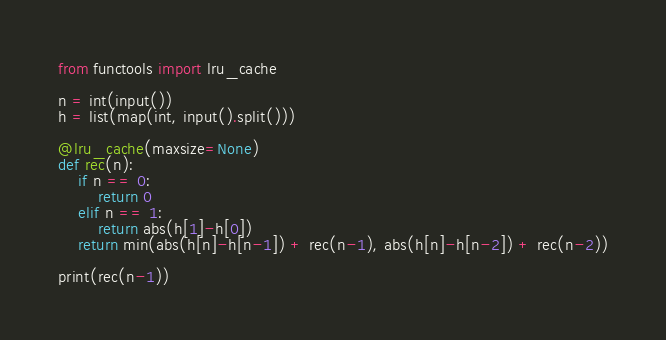Convert code to text. <code><loc_0><loc_0><loc_500><loc_500><_Python_>from functools import lru_cache

n = int(input())
h = list(map(int, input().split()))

@lru_cache(maxsize=None)
def rec(n):
    if n == 0:
        return 0
    elif n == 1:
        return abs(h[1]-h[0])
    return min(abs(h[n]-h[n-1]) + rec(n-1), abs(h[n]-h[n-2]) + rec(n-2))

print(rec(n-1))</code> 